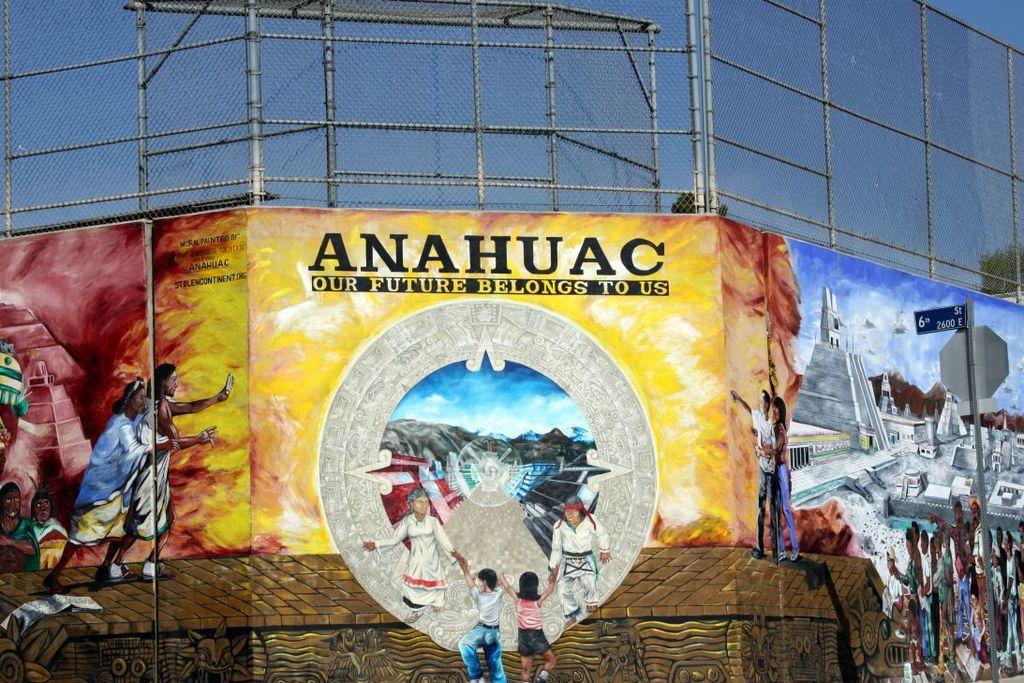Who does our future belong to?
Provide a short and direct response. Us. What is the name?
Your answer should be very brief. Anahuac. 